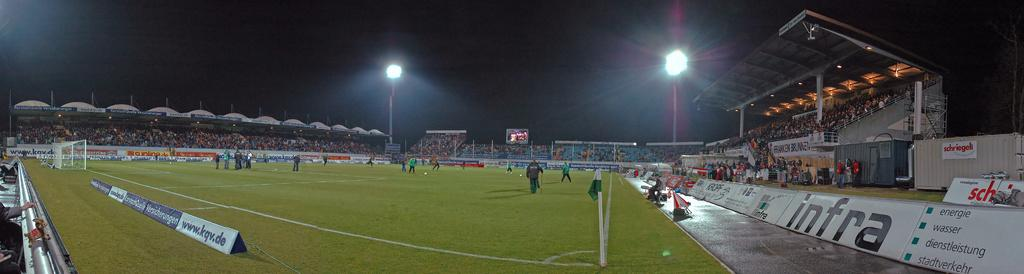<image>
Create a compact narrative representing the image presented. Players in a ball field with an ad for Infra 